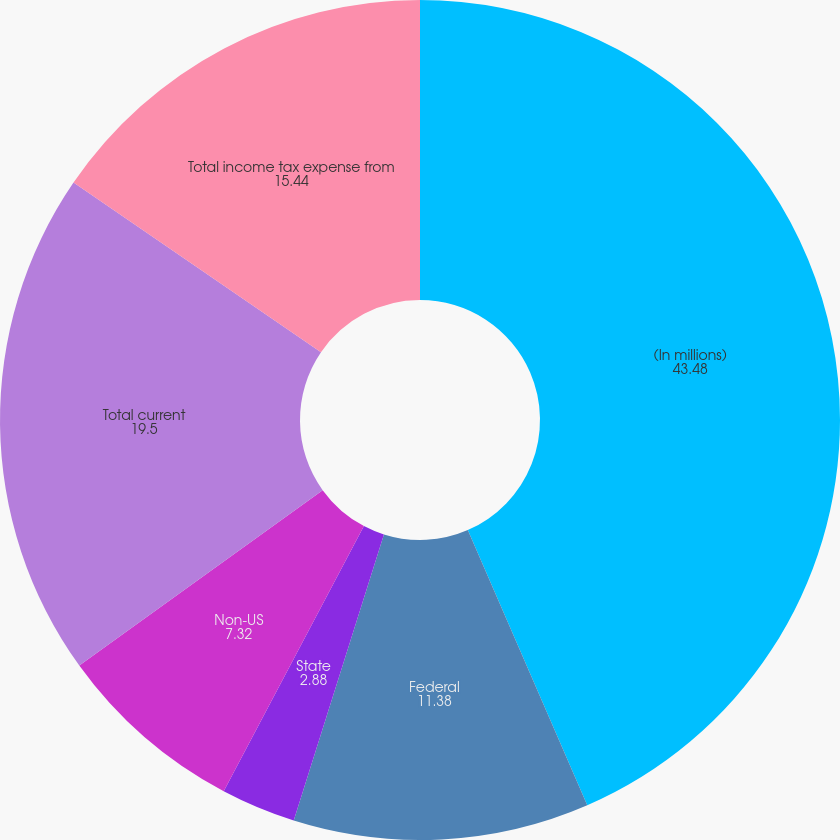Convert chart to OTSL. <chart><loc_0><loc_0><loc_500><loc_500><pie_chart><fcel>(In millions)<fcel>Federal<fcel>State<fcel>Non-US<fcel>Total current<fcel>Total income tax expense from<nl><fcel>43.48%<fcel>11.38%<fcel>2.88%<fcel>7.32%<fcel>19.5%<fcel>15.44%<nl></chart> 